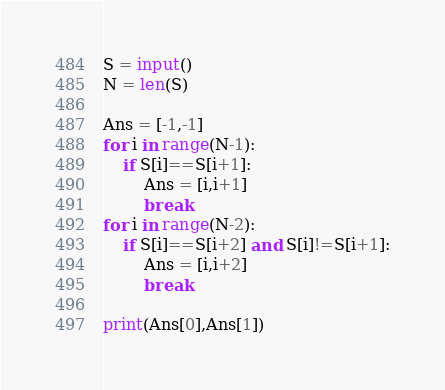<code> <loc_0><loc_0><loc_500><loc_500><_Python_>S = input()
N = len(S)

Ans = [-1,-1]
for i in range(N-1):
    if S[i]==S[i+1]:
        Ans = [i,i+1]
        break
for i in range(N-2):
    if S[i]==S[i+2] and S[i]!=S[i+1]:
        Ans = [i,i+2]
        break

print(Ans[0],Ans[1])</code> 